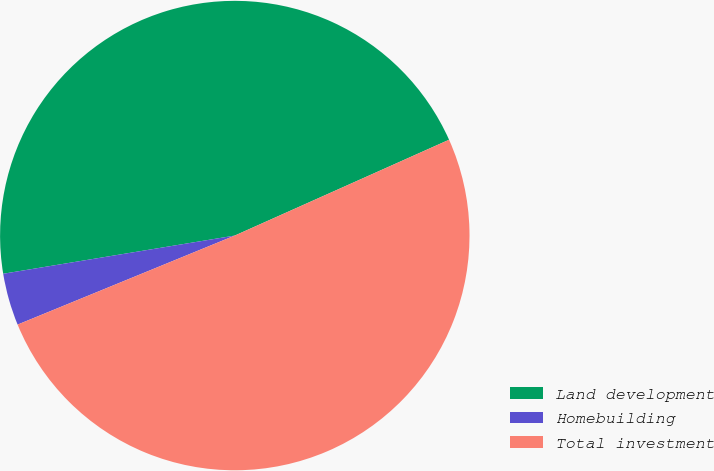<chart> <loc_0><loc_0><loc_500><loc_500><pie_chart><fcel>Land development<fcel>Homebuilding<fcel>Total investment<nl><fcel>45.91%<fcel>3.59%<fcel>50.5%<nl></chart> 